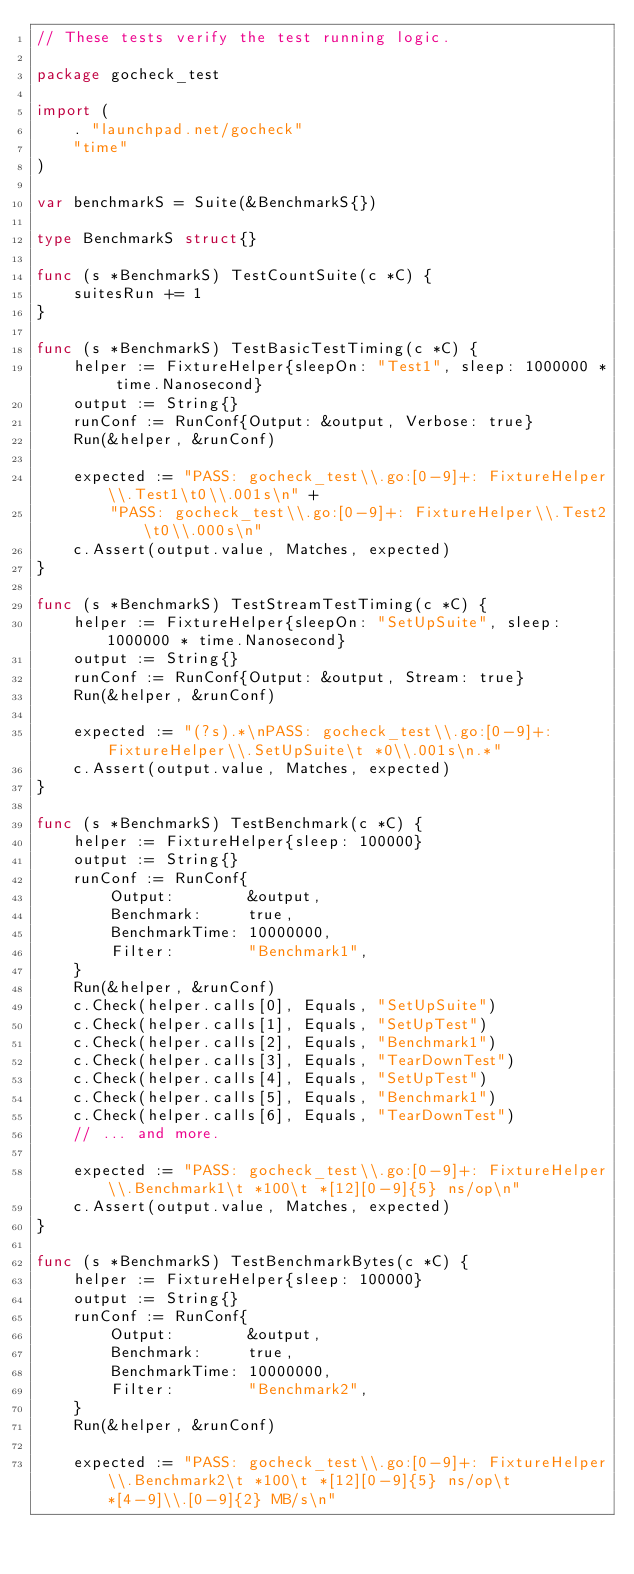<code> <loc_0><loc_0><loc_500><loc_500><_Go_>// These tests verify the test running logic.

package gocheck_test

import (
	. "launchpad.net/gocheck"
	"time"
)

var benchmarkS = Suite(&BenchmarkS{})

type BenchmarkS struct{}

func (s *BenchmarkS) TestCountSuite(c *C) {
	suitesRun += 1
}

func (s *BenchmarkS) TestBasicTestTiming(c *C) {
	helper := FixtureHelper{sleepOn: "Test1", sleep: 1000000 * time.Nanosecond}
	output := String{}
	runConf := RunConf{Output: &output, Verbose: true}
	Run(&helper, &runConf)

	expected := "PASS: gocheck_test\\.go:[0-9]+: FixtureHelper\\.Test1\t0\\.001s\n" +
		"PASS: gocheck_test\\.go:[0-9]+: FixtureHelper\\.Test2\t0\\.000s\n"
	c.Assert(output.value, Matches, expected)
}

func (s *BenchmarkS) TestStreamTestTiming(c *C) {
	helper := FixtureHelper{sleepOn: "SetUpSuite", sleep: 1000000 * time.Nanosecond}
	output := String{}
	runConf := RunConf{Output: &output, Stream: true}
	Run(&helper, &runConf)

	expected := "(?s).*\nPASS: gocheck_test\\.go:[0-9]+: FixtureHelper\\.SetUpSuite\t *0\\.001s\n.*"
	c.Assert(output.value, Matches, expected)
}

func (s *BenchmarkS) TestBenchmark(c *C) {
	helper := FixtureHelper{sleep: 100000}
	output := String{}
	runConf := RunConf{
		Output:        &output,
		Benchmark:     true,
		BenchmarkTime: 10000000,
		Filter:        "Benchmark1",
	}
	Run(&helper, &runConf)
	c.Check(helper.calls[0], Equals, "SetUpSuite")
	c.Check(helper.calls[1], Equals, "SetUpTest")
	c.Check(helper.calls[2], Equals, "Benchmark1")
	c.Check(helper.calls[3], Equals, "TearDownTest")
	c.Check(helper.calls[4], Equals, "SetUpTest")
	c.Check(helper.calls[5], Equals, "Benchmark1")
	c.Check(helper.calls[6], Equals, "TearDownTest")
	// ... and more.

	expected := "PASS: gocheck_test\\.go:[0-9]+: FixtureHelper\\.Benchmark1\t *100\t *[12][0-9]{5} ns/op\n"
	c.Assert(output.value, Matches, expected)
}

func (s *BenchmarkS) TestBenchmarkBytes(c *C) {
	helper := FixtureHelper{sleep: 100000}
	output := String{}
	runConf := RunConf{
		Output:        &output,
		Benchmark:     true,
		BenchmarkTime: 10000000,
		Filter:        "Benchmark2",
	}
	Run(&helper, &runConf)

	expected := "PASS: gocheck_test\\.go:[0-9]+: FixtureHelper\\.Benchmark2\t *100\t *[12][0-9]{5} ns/op\t *[4-9]\\.[0-9]{2} MB/s\n"</code> 